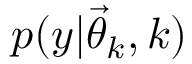<formula> <loc_0><loc_0><loc_500><loc_500>p ( y | { \vec { \theta } } _ { k } , k )</formula> 